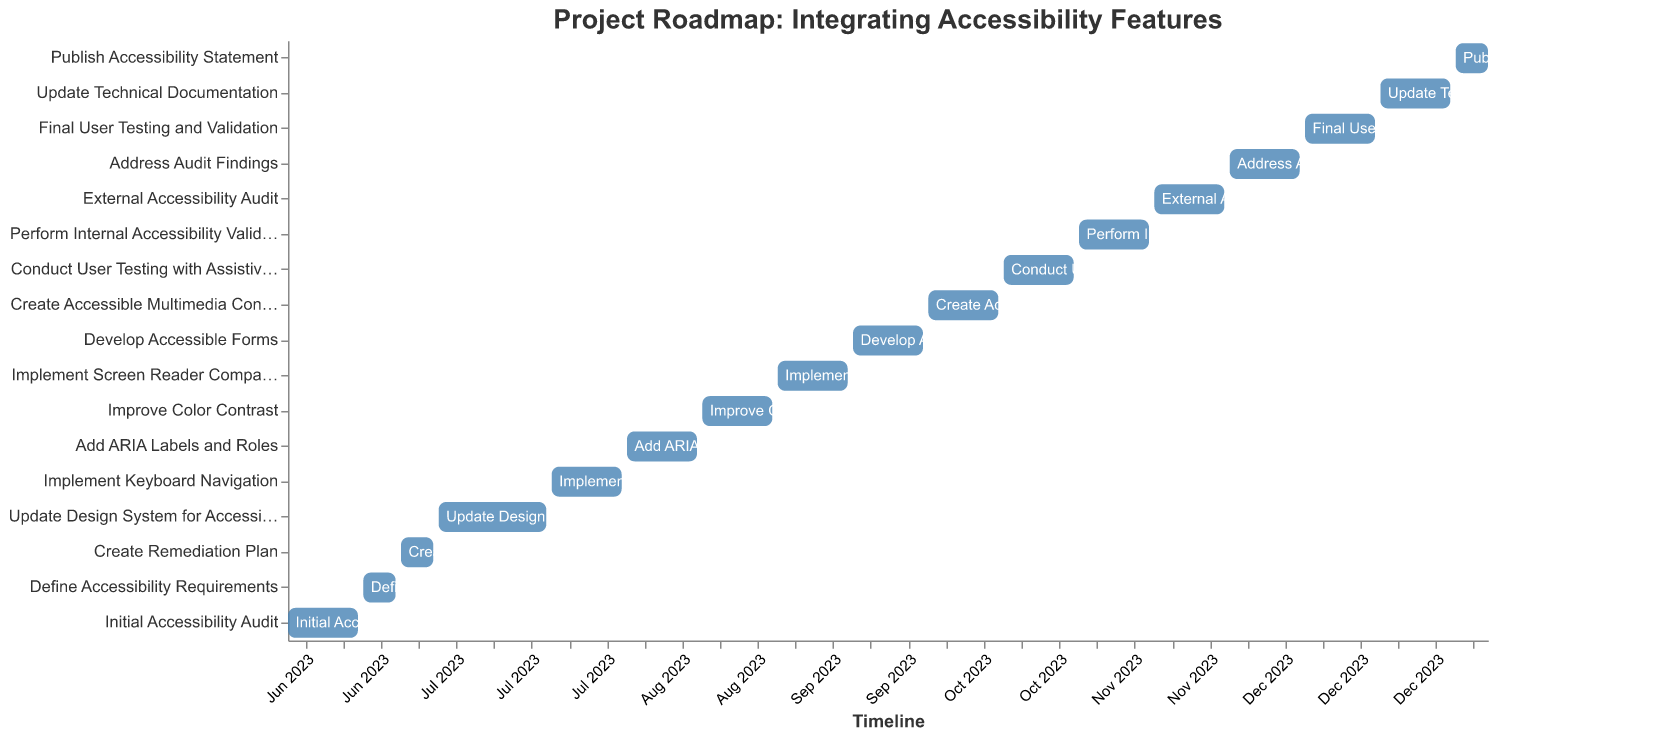What is the title of the Gantt chart? The title is usually displayed at the top of the chart. Here, it reads "Project Roadmap: Integrating Accessibility Features".
Answer: Project Roadmap: Integrating Accessibility Features Which task has the longest duration? By comparing the "Duration" values for each task, we see that "Update Design System for Accessibility" has the longest duration of 21 days.
Answer: Update Design System for Accessibility How many tasks are scheduled for the month of June 2023? The tasks in June 2023 are those starting and ending from 2023-06-01 to 2023-06-30. By referring to the data, these tasks are: "Initial Accessibility Audit", "Define Accessibility Requirements", "Create Remediation Plan", and "Update Design System for Accessibility".
Answer: 4 Which tasks follow immediately after "Implement Keyboard Navigation"? To find the next tasks, look for tasks starting on or immediately after 2023-08-03, which is the end date of "Implement Keyboard Navigation". "Add ARIA Labels and Roles" starts right after.
Answer: Add ARIA Labels and Roles What is the duration of "Develop Accessible Forms"? The duration for "Develop Accessible Forms" is given as 14 in the data.
Answer: 14 days Which tasks are part of the validation phase? The validation phase includes "Conduct User Testing with Assistive Technologies", "Perform Internal Accessibility Validation", "External Accessibility Audit", and "Final User Testing and Validation". These tasks focus on assessing and validating accessibility.
Answer: Conduct User Testing with Assistive Technologies, Perform Internal Accessibility Validation, External Accessibility Audit, Final User Testing and Validation Which two tasks have the shortest durations? By looking at the "Duration" values, "Define Accessibility Requirements" and "Publish Accessibility Statement" both have the shortest duration of 7 days.
Answer: Define Accessibility Requirements, Publish Accessibility Statement What is the total duration (in days) from the start of "Initial Accessibility Audit" to the end of "Publish Accessibility Statement"? The start date of "Initial Accessibility Audit" is 2023-06-01, and the end date of "Publish Accessibility Statement" is 2024-01-10. Counting the days from 2023-06-01 to 2024-01-10, we get 224 days.
Answer: 224 days 